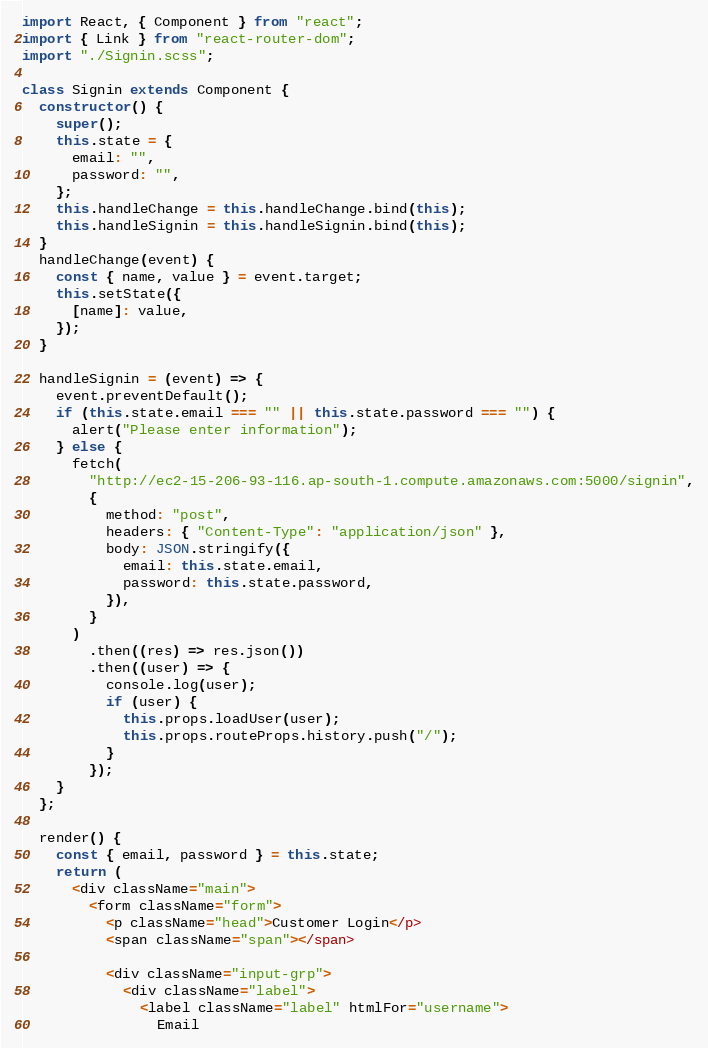Convert code to text. <code><loc_0><loc_0><loc_500><loc_500><_JavaScript_>import React, { Component } from "react";
import { Link } from "react-router-dom";
import "./Signin.scss";

class Signin extends Component {
  constructor() {
    super();
    this.state = {
      email: "",
      password: "",
    };
    this.handleChange = this.handleChange.bind(this);
    this.handleSignin = this.handleSignin.bind(this);
  }
  handleChange(event) {
    const { name, value } = event.target;
    this.setState({
      [name]: value,
    });
  }

  handleSignin = (event) => {
    event.preventDefault();
    if (this.state.email === "" || this.state.password === "") {
      alert("Please enter information");
    } else {
      fetch(
        "http://ec2-15-206-93-116.ap-south-1.compute.amazonaws.com:5000/signin",
        {
          method: "post",
          headers: { "Content-Type": "application/json" },
          body: JSON.stringify({
            email: this.state.email,
            password: this.state.password,
          }),
        }
      )
        .then((res) => res.json())
        .then((user) => {
          console.log(user);
          if (user) {
            this.props.loadUser(user);
            this.props.routeProps.history.push("/");
          }
        });
    }
  };

  render() {
    const { email, password } = this.state;
    return (
      <div className="main">
        <form className="form">
          <p className="head">Customer Login</p>
          <span className="span"></span>

          <div className="input-grp">
            <div className="label">
              <label className="label" htmlFor="username">
                Email</code> 